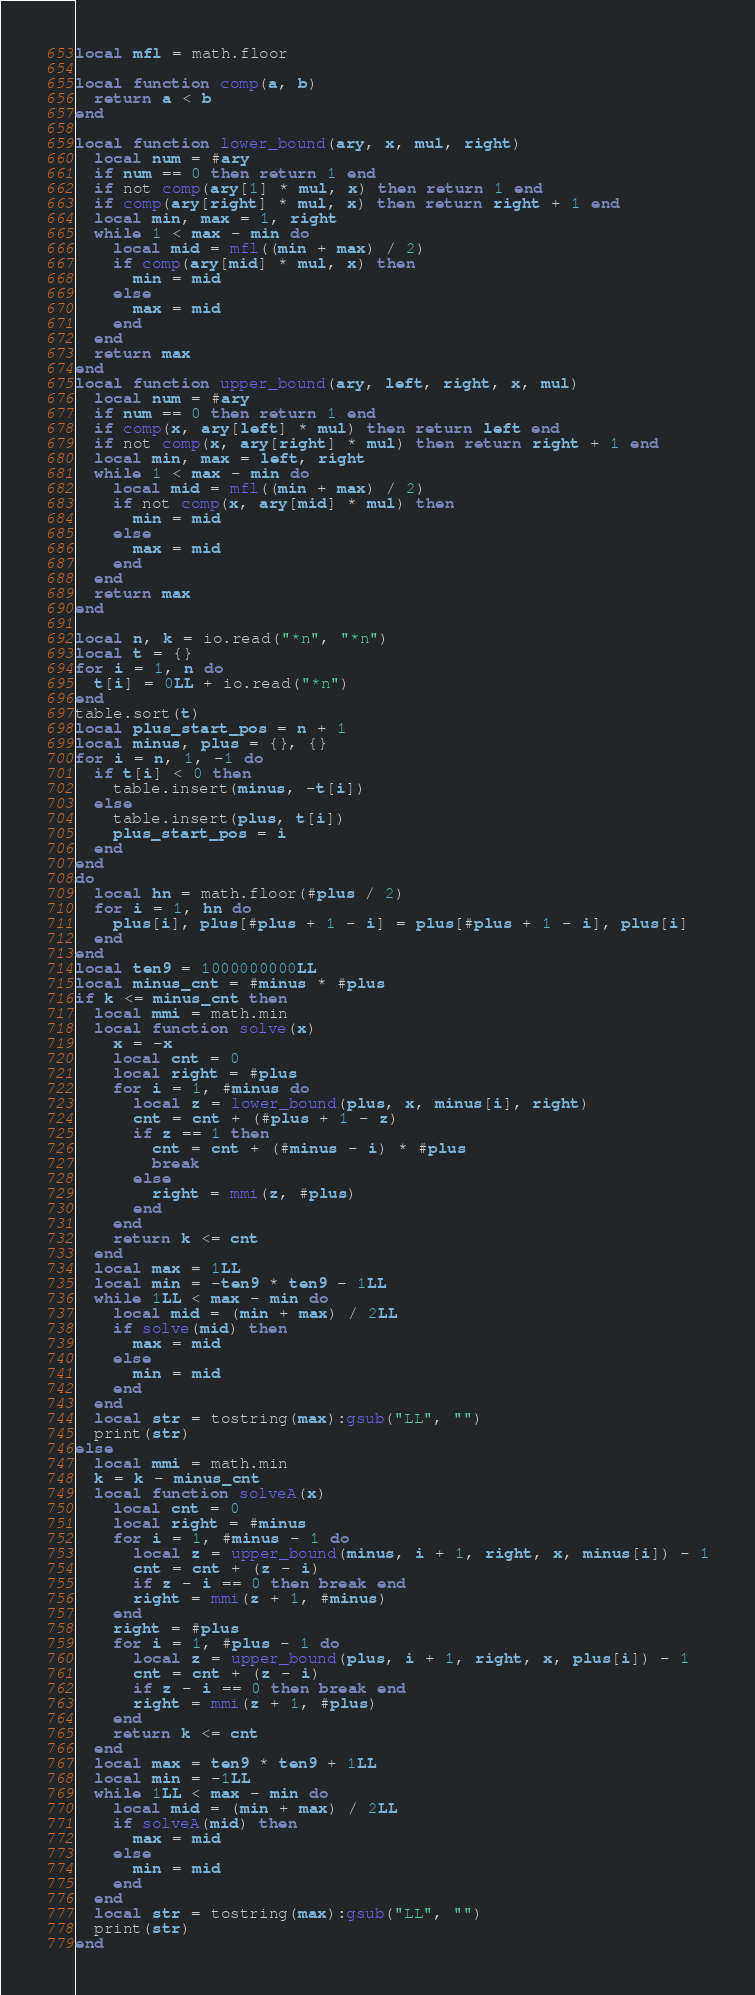Convert code to text. <code><loc_0><loc_0><loc_500><loc_500><_Lua_>local mfl = math.floor

local function comp(a, b)
  return a < b
end

local function lower_bound(ary, x, mul, right)
  local num = #ary
  if num == 0 then return 1 end
  if not comp(ary[1] * mul, x) then return 1 end
  if comp(ary[right] * mul, x) then return right + 1 end
  local min, max = 1, right
  while 1 < max - min do
    local mid = mfl((min + max) / 2)
    if comp(ary[mid] * mul, x) then
      min = mid
    else
      max = mid
    end
  end
  return max
end
local function upper_bound(ary, left, right, x, mul)
  local num = #ary
  if num == 0 then return 1 end
  if comp(x, ary[left] * mul) then return left end
  if not comp(x, ary[right] * mul) then return right + 1 end
  local min, max = left, right
  while 1 < max - min do
    local mid = mfl((min + max) / 2)
    if not comp(x, ary[mid] * mul) then
      min = mid
    else
      max = mid
    end
  end
  return max
end

local n, k = io.read("*n", "*n")
local t = {}
for i = 1, n do
  t[i] = 0LL + io.read("*n")
end
table.sort(t)
local plus_start_pos = n + 1
local minus, plus = {}, {}
for i = n, 1, -1 do
  if t[i] < 0 then
    table.insert(minus, -t[i])
  else
    table.insert(plus, t[i])
    plus_start_pos = i
  end
end
do
  local hn = math.floor(#plus / 2)
  for i = 1, hn do
    plus[i], plus[#plus + 1 - i] = plus[#plus + 1 - i], plus[i]
  end
end
local ten9 = 1000000000LL
local minus_cnt = #minus * #plus
if k <= minus_cnt then
  local mmi = math.min
  local function solve(x)
    x = -x
    local cnt = 0
    local right = #plus
    for i = 1, #minus do
      local z = lower_bound(plus, x, minus[i], right)
      cnt = cnt + (#plus + 1 - z)
      if z == 1 then
        cnt = cnt + (#minus - i) * #plus
        break
      else
        right = mmi(z, #plus)
      end
    end
    return k <= cnt
  end
  local max = 1LL
  local min = -ten9 * ten9 - 1LL
  while 1LL < max - min do
    local mid = (min + max) / 2LL
    if solve(mid) then
      max = mid
    else
      min = mid
    end
  end
  local str = tostring(max):gsub("LL", "")
  print(str)
else
  local mmi = math.min
  k = k - minus_cnt
  local function solveA(x)
    local cnt = 0
    local right = #minus
    for i = 1, #minus - 1 do
      local z = upper_bound(minus, i + 1, right, x, minus[i]) - 1
      cnt = cnt + (z - i)
      if z - i == 0 then break end
      right = mmi(z + 1, #minus)
    end
    right = #plus
    for i = 1, #plus - 1 do
      local z = upper_bound(plus, i + 1, right, x, plus[i]) - 1
      cnt = cnt + (z - i)
      if z - i == 0 then break end
      right = mmi(z + 1, #plus)
    end
    return k <= cnt
  end
  local max = ten9 * ten9 + 1LL
  local min = -1LL
  while 1LL < max - min do
    local mid = (min + max) / 2LL
    if solveA(mid) then
      max = mid
    else
      min = mid
    end
  end
  local str = tostring(max):gsub("LL", "")
  print(str)
end
</code> 